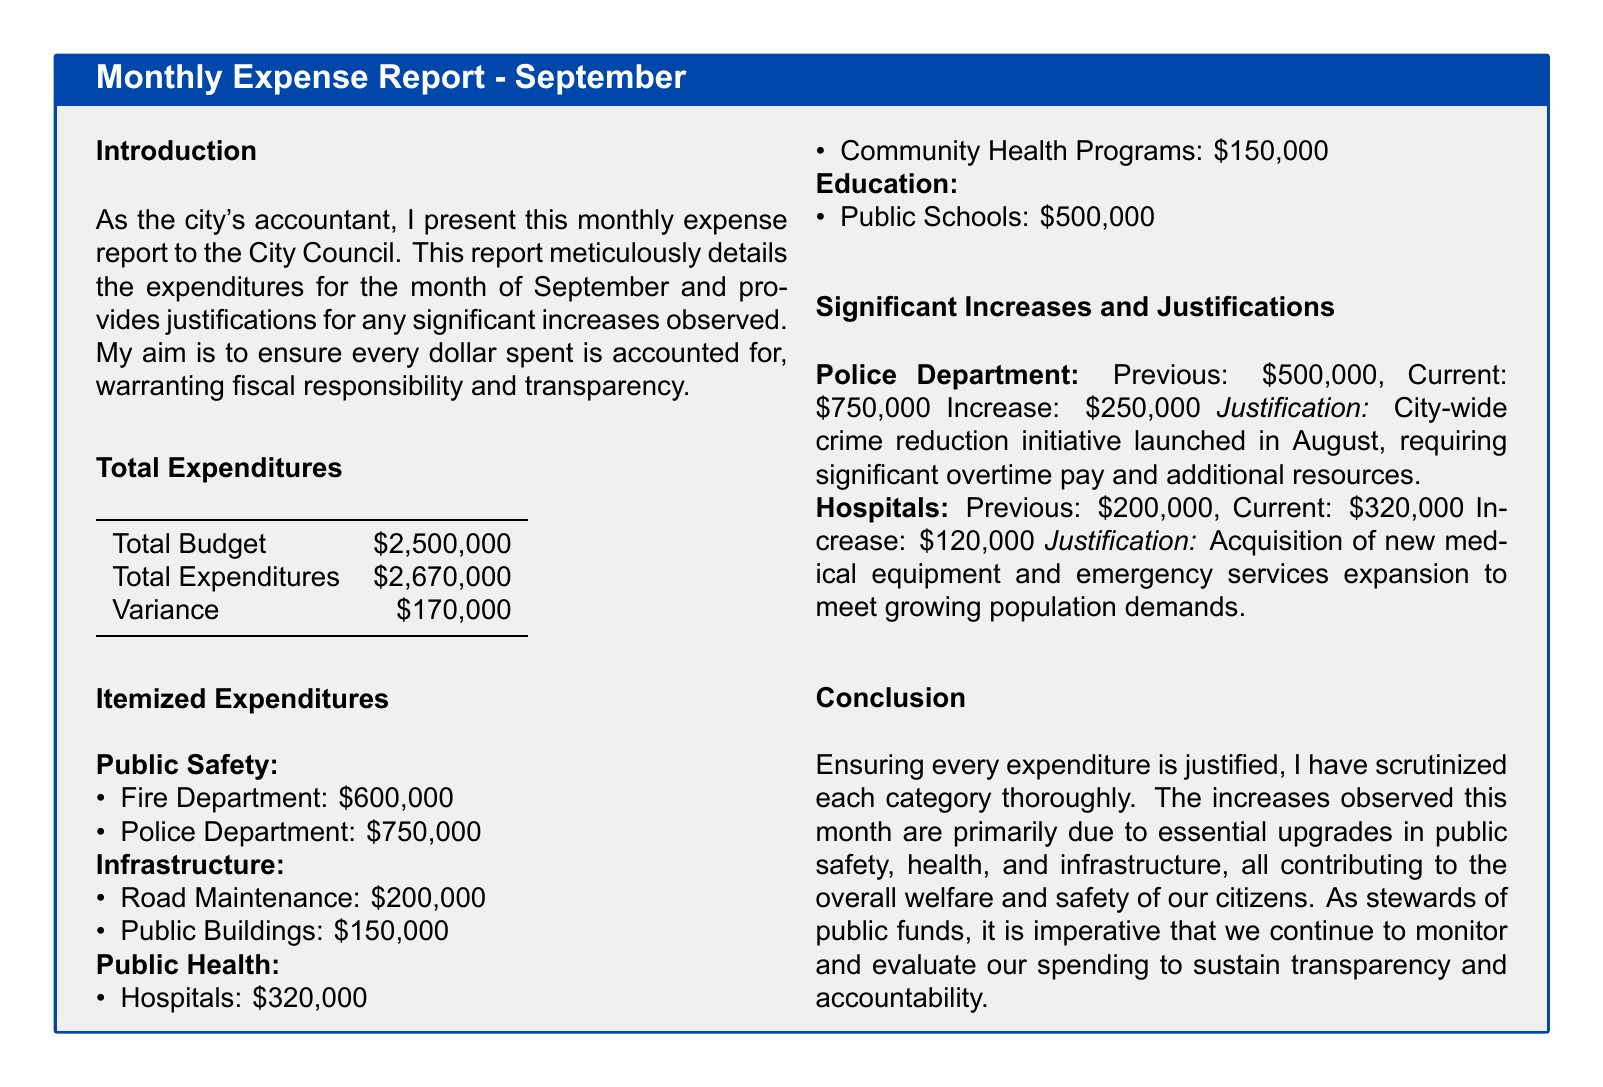what is the total budget? The total budget is explicitly stated in the document as the allocated amount for the city council's expenses.
Answer: $2,500,000 what is the total expenditures? The total expenditures reflect all the expenses incurred during the month, which is found in the document summary.
Answer: $2,670,000 what is the variance? The variance indicates the difference between the total budget and total expenditures and is calculated from the previous two figures.
Answer: $170,000 how much was spent on the Police Department? The expenditure on the Police Department is provided in the itemized expenditures section of the report.
Answer: $750,000 what was the previous expenditure for the Hospitals? The previous expenditure for the Hospitals is mentioned as the former amount before the increase in the recent report.
Answer: $200,000 what was the increase in expenditure for the Police Department? The increase reflects the additional spending for the Police Department this month compared to the previous month, specified in the justifications section.
Answer: $250,000 what is the justification for the increase in Hospital expenditures? The justification for the increase aims to explain the necessity of additional funds for the hospitals, as outlined in the increase section.
Answer: Acquisition of new medical equipment and emergency services expansion what percentage of the total expenditures is allocated to Education? The expenditures on Education are included in the itemized sections, allowing for the calculation of its percentage of total expenditures.
Answer: 18.7% why was there an increase in the Police Department spending? The justification for the increase in the Police Department spending provides reasons supporting the additional financial allocation.
Answer: City-wide crime reduction initiative 